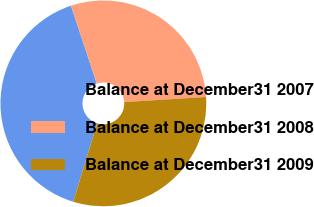<chart> <loc_0><loc_0><loc_500><loc_500><pie_chart><fcel>Balance at December31 2007<fcel>Balance at December31 2008<fcel>Balance at December31 2009<nl><fcel>40.16%<fcel>29.11%<fcel>30.74%<nl></chart> 